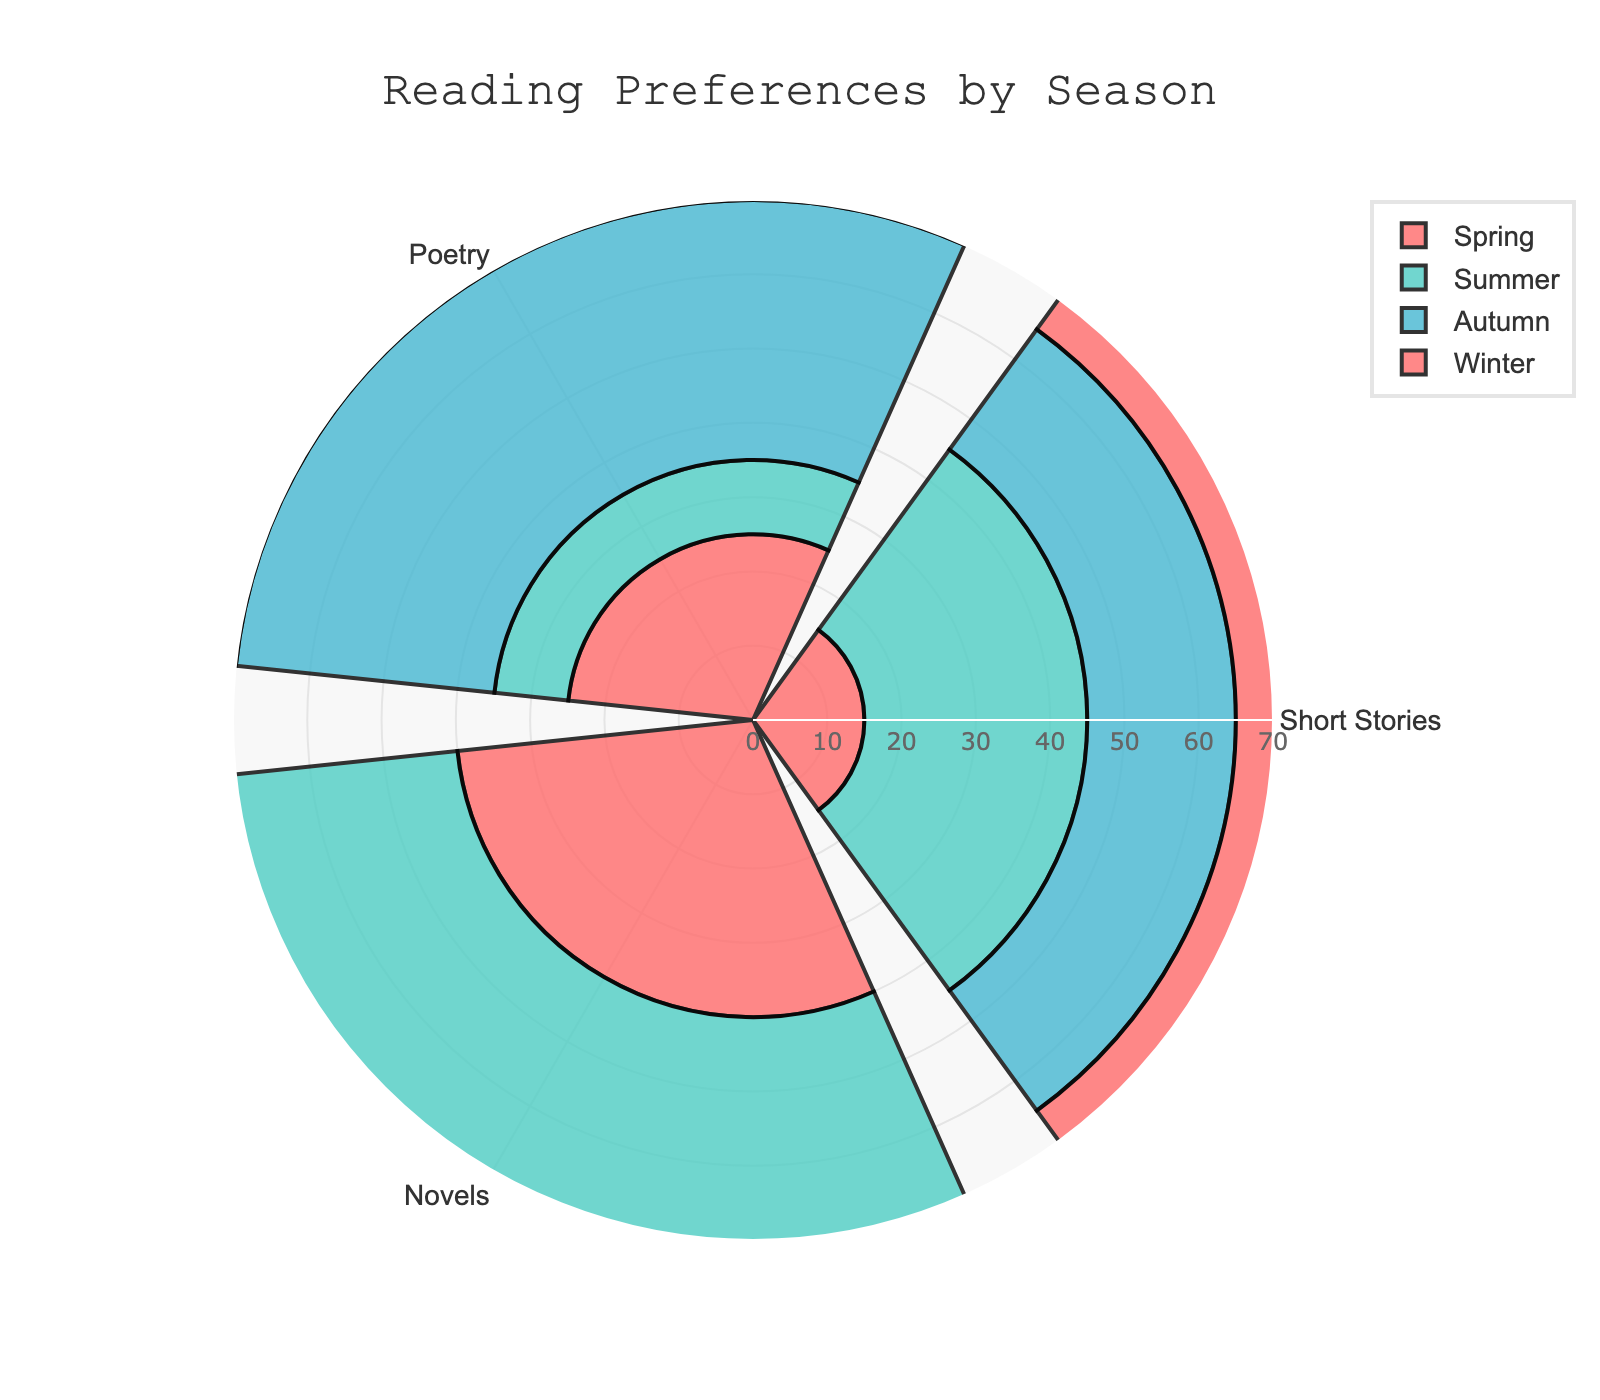What season has the most preference for reading novels? By observing the heights corresponding to novels in the rose chart, we can see that summer has the highest value with 60.
Answer: Summer How many seasons show a preference for poetry higher than 30? By looking at the radial values for poetry across the seasons, autumn and winter have 35 and 45, respectively, which are both higher than 30.
Answer: 2 Which season has the least preference for short stories? Comparing the radial values for short stories across all seasons, spring has the lowest value with 15.
Answer: Spring What is the sum of preferences for reading novels in spring and autumn? The values for reading novels in spring and autumn are 40 and 45, respectively. Summing them up, 40 + 45 = 85.
Answer: 85 Which category has the highest reading preference in each season? For each season, identify the highest radial value:
- Spring: Novels (40)
- Summer: Novels (60)
- Autumn: Novels (45)
- Winter: Poetry (45)
Answer: Novels for spring, summer, autumn; Poetry for winter Is the preference for reading short stories in winter more than spring? Comparing the radial values for short stories, winter has 25 while spring has 15, and 25 is greater than 15.
Answer: Yes What is the difference between the highest and lowest preferences for poetry? The highest value for poetry is 45 (winter), and the lowest is 10 (summer). The difference is 45 - 10 = 35.
Answer: 35 Which season shows a balance (equal preference) between at least two categories? Observing the plot, spring shows equal preference for poetry (25) and short stories (15).
Answer: Spring (for poetry and short stories) 